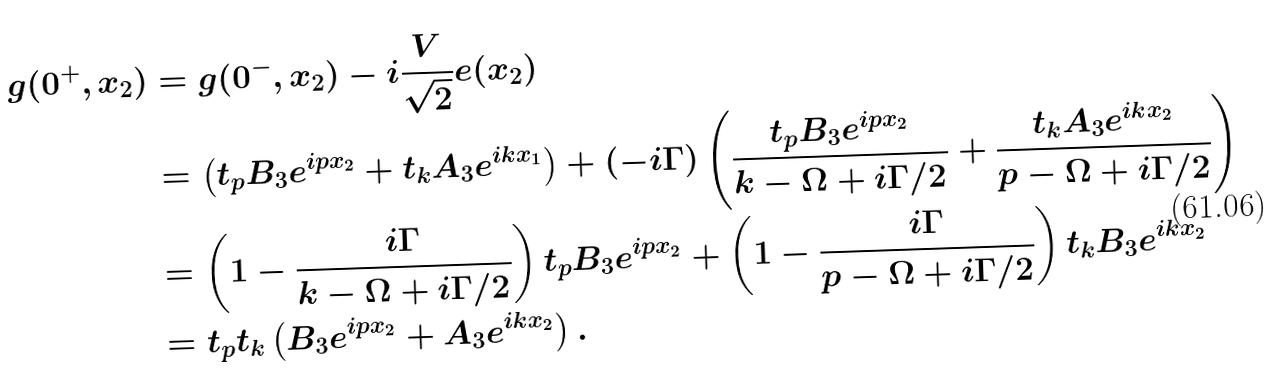<formula> <loc_0><loc_0><loc_500><loc_500>g ( 0 ^ { + } , x _ { 2 } ) & = g ( 0 ^ { - } , x _ { 2 } ) - i \frac { V } { \sqrt { 2 } } e ( x _ { 2 } ) \\ & = \left ( t _ { p } B _ { 3 } e ^ { i p x _ { 2 } } + t _ { k } A _ { 3 } e ^ { i k x _ { 1 } } \right ) + ( - i \Gamma ) \left ( \frac { t _ { p } B _ { 3 } e ^ { i p x _ { 2 } } } { k - \Omega + i \Gamma / 2 } + \frac { t _ { k } A _ { 3 } e ^ { i k x _ { 2 } } } { p - \Omega + i \Gamma / 2 } \right ) \\ & = \left ( 1 - \frac { i \Gamma } { k - \Omega + i \Gamma / 2 } \right ) t _ { p } B _ { 3 } e ^ { i p x _ { 2 } } + \left ( 1 - \frac { i \Gamma } { p - \Omega + i \Gamma / 2 } \right ) t _ { k } B _ { 3 } e ^ { i k x _ { 2 } } \\ & = t _ { p } t _ { k } \left ( B _ { 3 } e ^ { i p x _ { 2 } } + A _ { 3 } e ^ { i k x _ { 2 } } \right ) .</formula> 